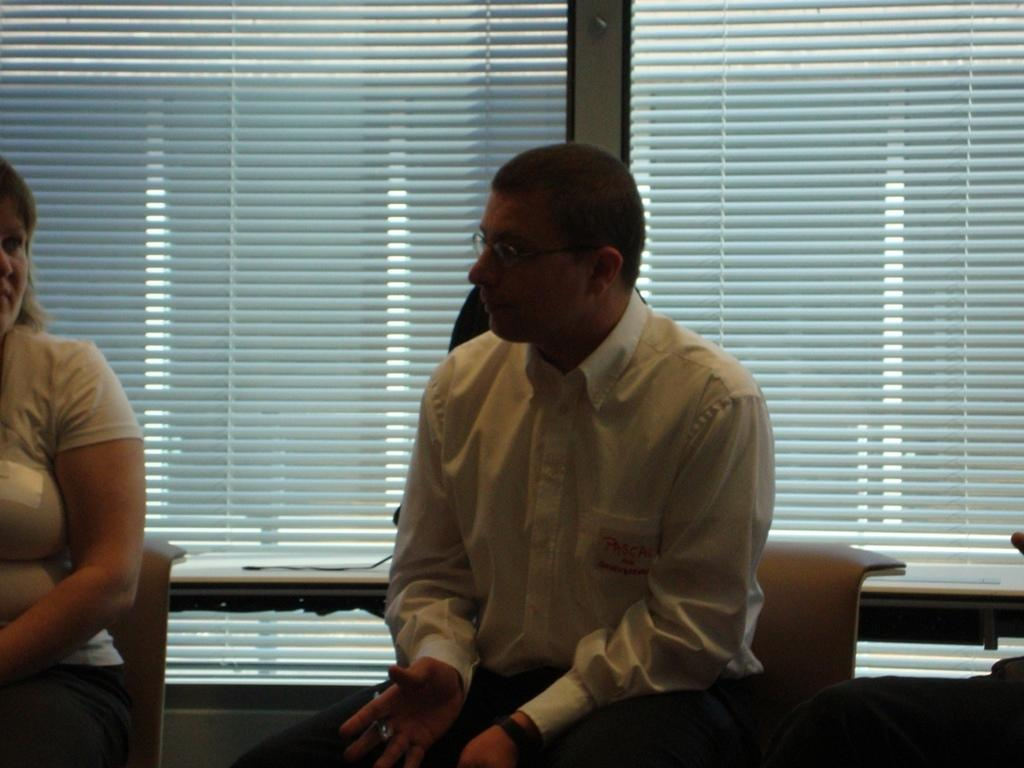How many people are sitting in the image? There are two persons sitting in the image. Can you describe the clothing of the person in front? The person in front is wearing a white shirt and black pants. What can be seen in the background of the image? There is a window visible in the background of the image. What type of circle can be seen on the wall in the image? There is no circle present on the wall in the image. Can you describe the playground equipment visible through the window? There is no playground equipment visible through the window in the image. 